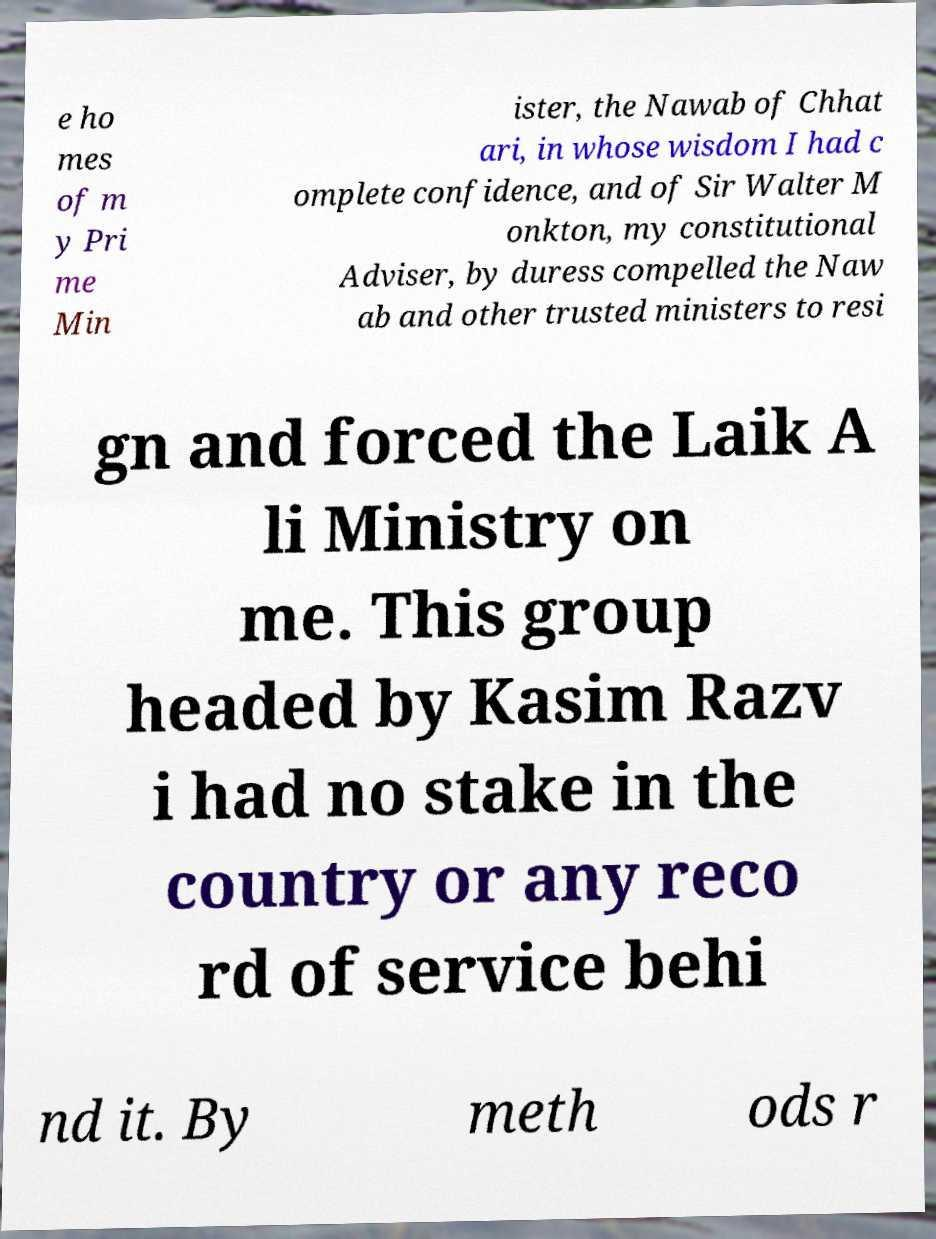Could you extract and type out the text from this image? e ho mes of m y Pri me Min ister, the Nawab of Chhat ari, in whose wisdom I had c omplete confidence, and of Sir Walter M onkton, my constitutional Adviser, by duress compelled the Naw ab and other trusted ministers to resi gn and forced the Laik A li Ministry on me. This group headed by Kasim Razv i had no stake in the country or any reco rd of service behi nd it. By meth ods r 